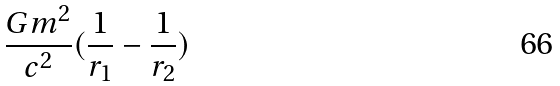<formula> <loc_0><loc_0><loc_500><loc_500>\frac { G m ^ { 2 } } { c ^ { 2 } } ( \frac { 1 } { r _ { 1 } } - \frac { 1 } { r _ { 2 } } )</formula> 